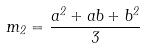<formula> <loc_0><loc_0><loc_500><loc_500>m _ { 2 } = \frac { a ^ { 2 } + a b + b ^ { 2 } } { 3 }</formula> 